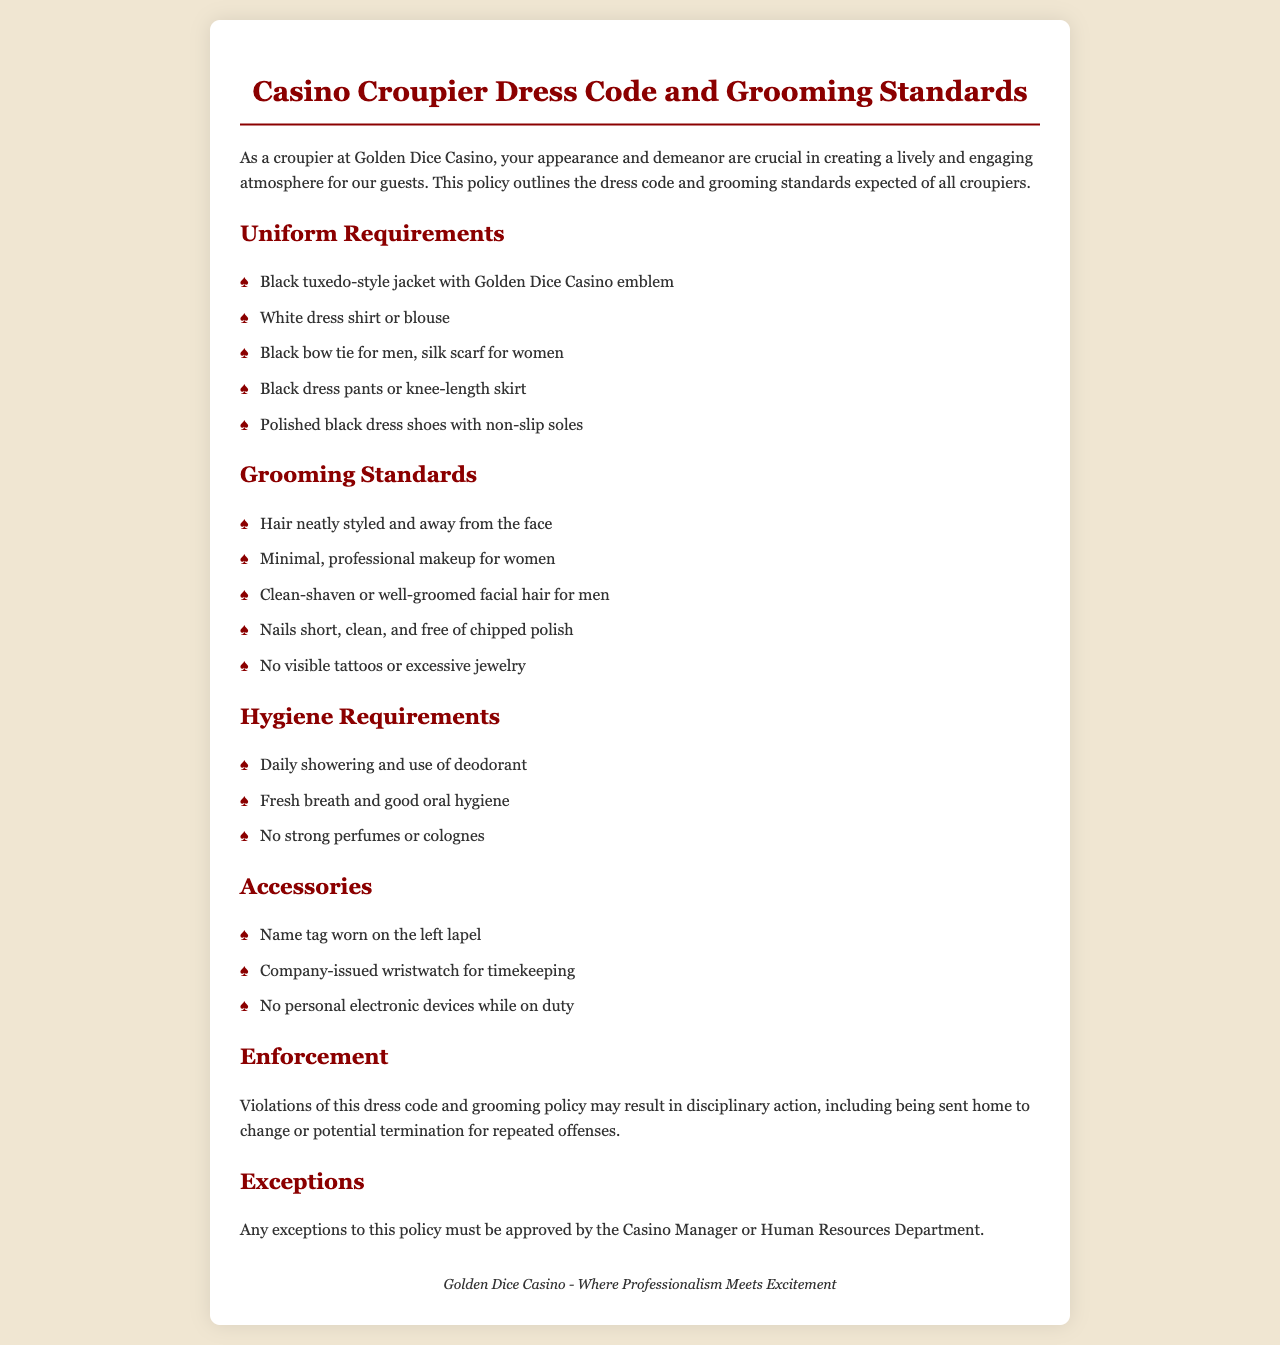What is the color of the tuxedo-style jacket? The dress code states that croupiers must wear a black tuxedo-style jacket.
Answer: black What kind of jewelry is allowed? The grooming standards indicate that no excessive jewelry is allowed.
Answer: no excessive jewelry What must men wear as part of their uniform? According to the uniform requirements, men must wear a black bow tie as part of their outfit.
Answer: black bow tie What should croupiers do if they need an exception to the dress code? The document specifies that any exceptions to the dress code must be approved by the Casino Manager or Human Resources Department.
Answer: approved by the Casino Manager or Human Resources What is required for hair grooming? The grooming standards require that hair be neatly styled and away from the face.
Answer: neatly styled and away from the face How should nails be maintained? The grooming guidelines state that nails should be short, clean, and free of chipped polish.
Answer: short, clean, and free of chipped polish What footwear is specified in the dress code? Croupiers are required to wear polished black dress shoes with non-slip soles.
Answer: polished black dress shoes with non-slip soles What is a requirement regarding personal hygiene? The hygiene requirements emphasize daily showering and use of deodorant.
Answer: daily showering and use of deodorant What is one consequence of violating the dress code? The document states that violations may result in being sent home to change.
Answer: being sent home to change 